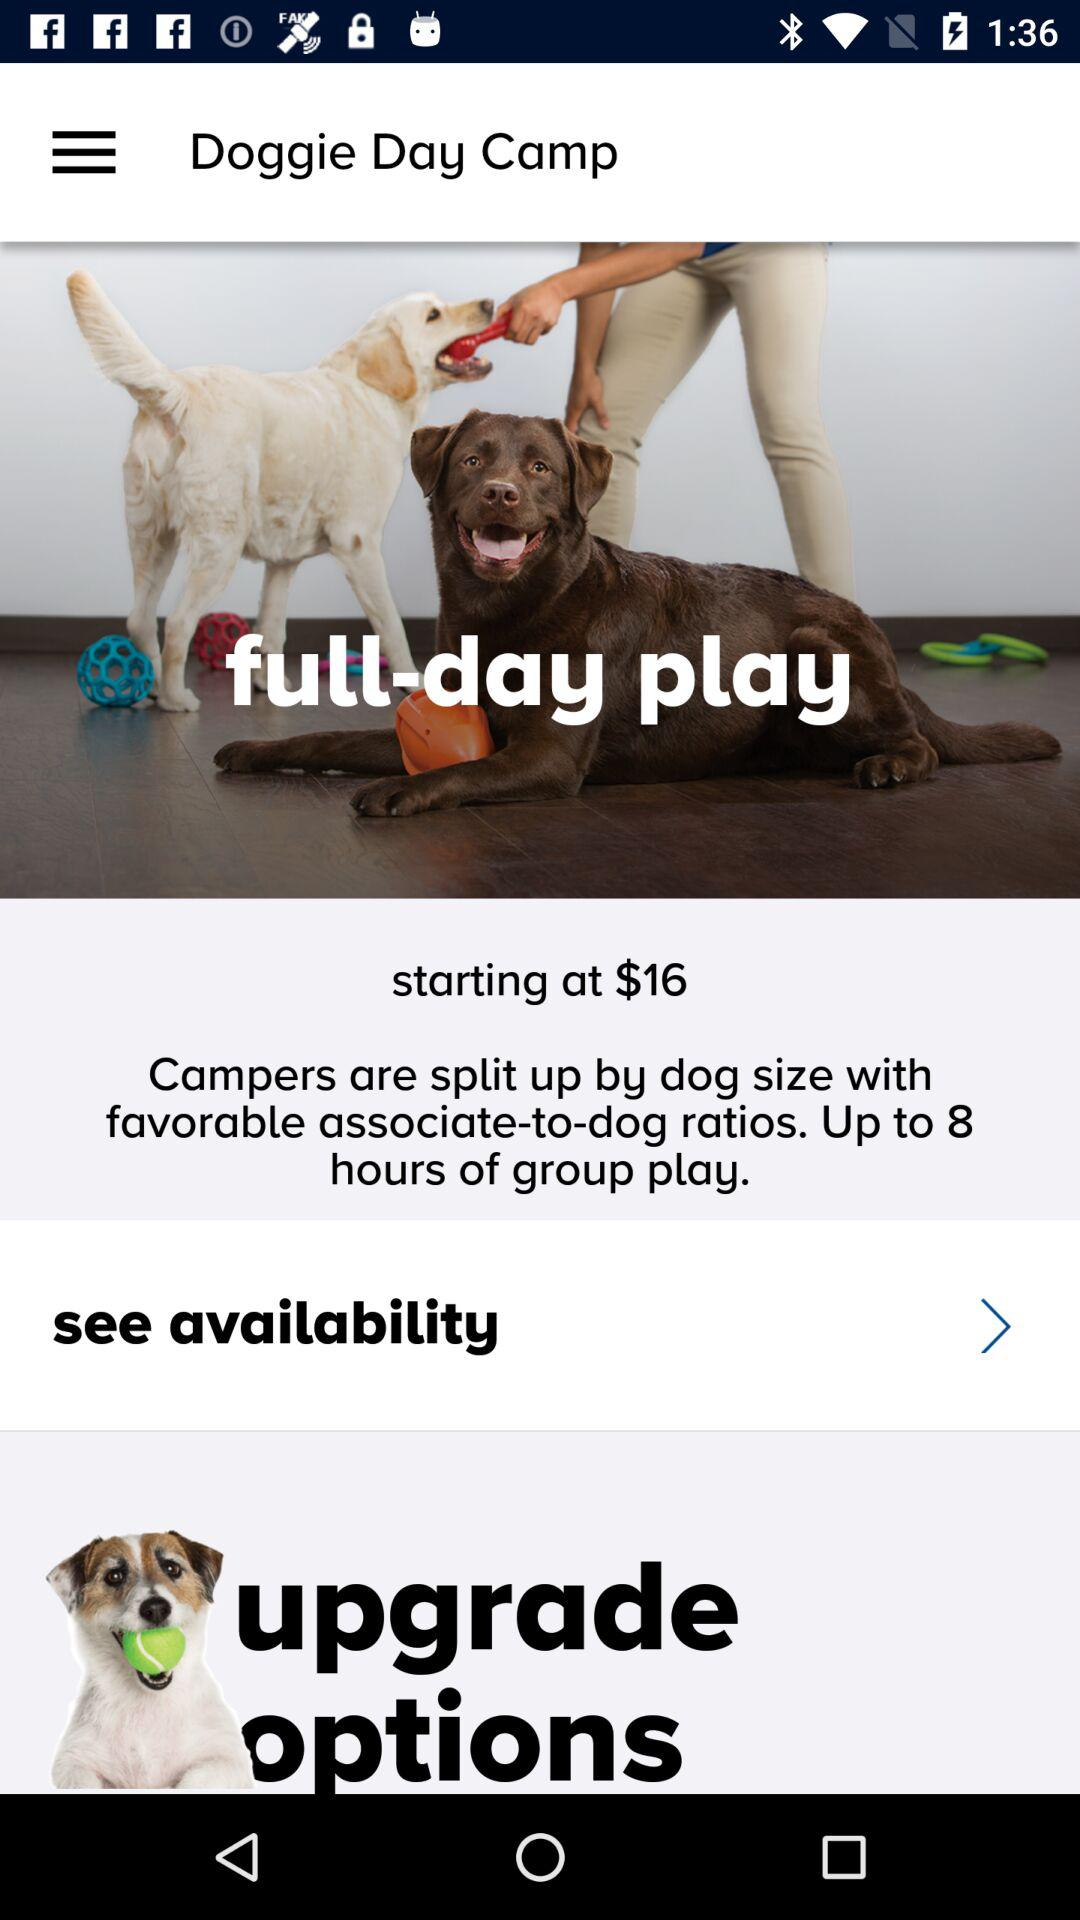How many hours of group play does the full-day play offer?
Answer the question using a single word or phrase. Up to 8 hours 